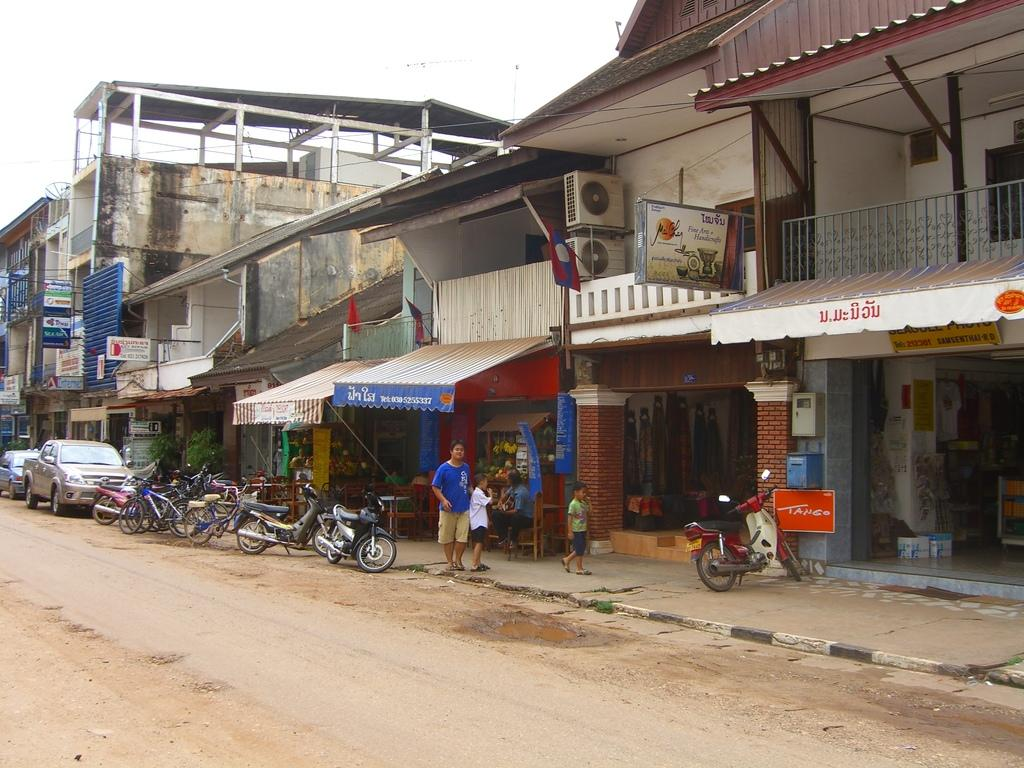Who or what can be seen in the image? There are people in the image. What else is present in the image besides people? There are vehicles and bicycles in the image. What can be seen in the background of the image? There are buildings and flags in the background of the image. Are there any other structures or objects in the image? Yes, there are hoardings in the image. What type of calculator is being used by the people in the image? There is no calculator present in the image. Can you tell me how many bedrooms are visible in the image? There are no bedrooms visible in the image. 